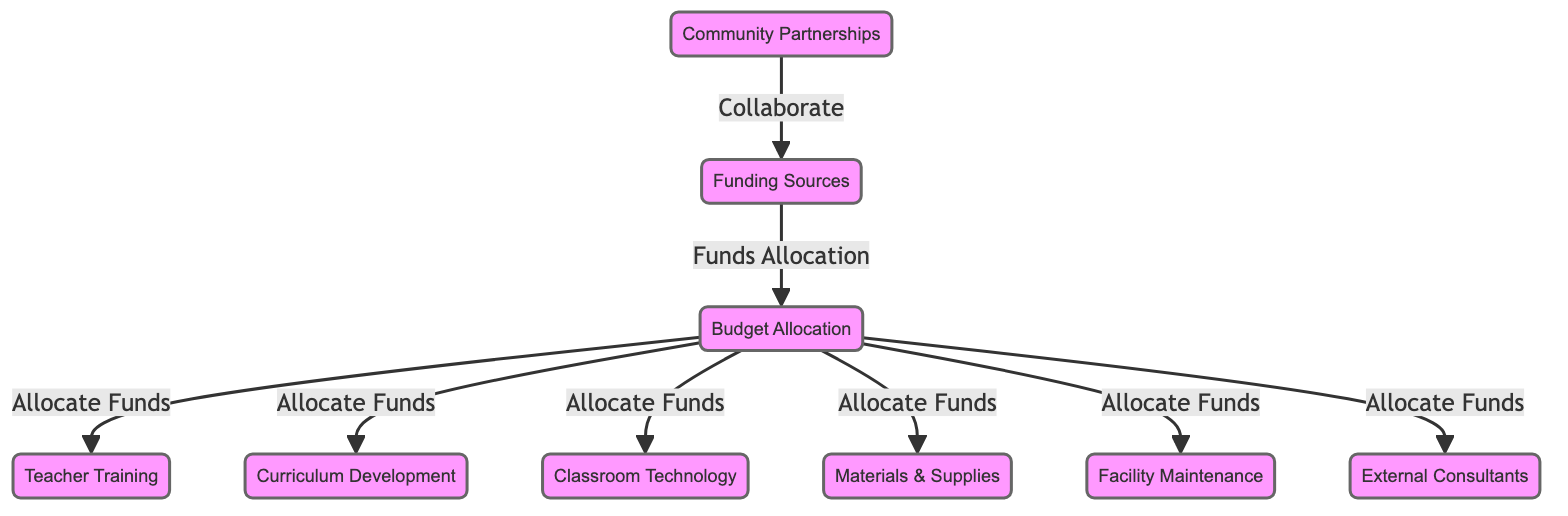What are the funding sources' roles in project-based learning? The funding sources collaborate with community partnerships, indicating that these partnerships are critical in securing financial support for project-based learning initiatives.
Answer: Collaborate How many nodes are present in the diagram? The diagram includes a total of eight nodes: Funding Sources, Budget Allocation, Teacher Training, Curriculum Development, Classroom Technology, Materials & Supplies, Facility Maintenance, and External Consultants.
Answer: Eight What connects community partnerships to funding sources? The flow from community partnerships to funding sources is labeled as "Collaborate," showing the relationship that these partnerships work together to acquire funding.
Answer: Collaborate How does the budget allocation relate to teacher training? The budget allocation node directs funds to the teacher training node, showing that funding supports the professional development of teachers.
Answer: Allocate Funds Which node has the most connections in the diagram? The budget allocation node has multiple outbound connections to teacher training, curriculum development, classroom technology, materials & supplies, facility maintenance, and external consultants, indicating it is central to resource distribution.
Answer: Budget Allocation What does the budget allocation directly allocate funds to? The budget allocation allocates funds to six specific nodes: teacher training, curriculum development, classroom technology, materials & supplies, facility maintenance, and external consultants as indicated by the arrows pointing from budget allocation.
Answer: Six What role do external consultants play in project-based learning funding? External consultants are part of the budget allocation, highlighting their significance in the implementation process as they receive funds to provide expertise or support.
Answer: Funds Allocation What is necessary for a successful implementation of project-based learning according to the diagram? Successful implementation requires collaboration, budget allocation, and investment in various areas including teacher training, technology, and supplies, as illustrated by the connections in the diagram.
Answer: Collaboration and Budget Allocation 